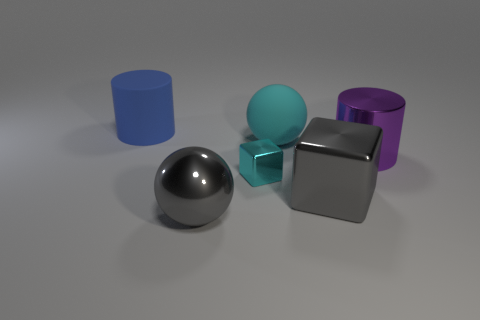Add 2 red matte things. How many objects exist? 8 Subtract all spheres. How many objects are left? 4 Subtract all large yellow cubes. Subtract all big blue matte things. How many objects are left? 5 Add 1 big gray shiny things. How many big gray shiny things are left? 3 Add 1 purple spheres. How many purple spheres exist? 1 Subtract 0 brown blocks. How many objects are left? 6 